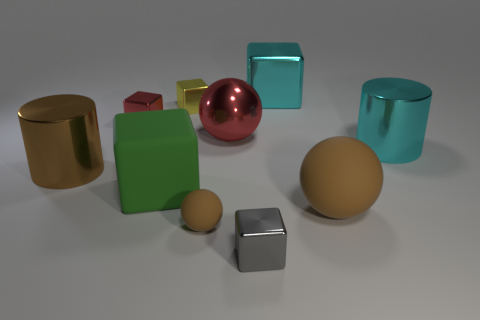Subtract 2 cubes. How many cubes are left? 3 Subtract all brown cubes. Subtract all green cylinders. How many cubes are left? 5 Subtract all cylinders. How many objects are left? 8 Add 8 large gray cubes. How many large gray cubes exist? 8 Subtract 0 purple blocks. How many objects are left? 10 Subtract all purple shiny cubes. Subtract all red metallic things. How many objects are left? 8 Add 8 green things. How many green things are left? 9 